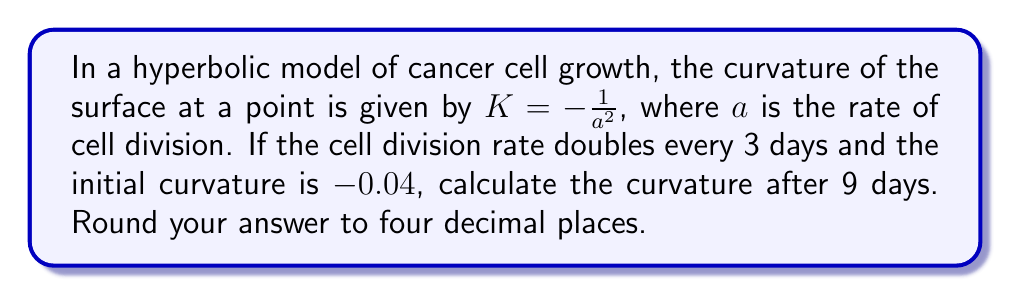Help me with this question. Let's approach this step-by-step:

1) The initial curvature is given as $K_0 = -0.04$

2) We know that $K = -\frac{1}{a^2}$, so initially:
   $-0.04 = -\frac{1}{a_0^2}$

3) Solving for $a_0$:
   $a_0^2 = \frac{1}{0.04} = 25$
   $a_0 = 5$

4) The cell division rate doubles every 3 days. After 9 days, it will have doubled 3 times.
   $a_9 = a_0 \cdot 2^3 = 5 \cdot 8 = 40$

5) Now we can calculate the new curvature:
   $K_9 = -\frac{1}{a_9^2} = -\frac{1}{40^2} = -\frac{1}{1600} = -0.000625$

6) Rounding to four decimal places: $-0.0006$
Answer: $-0.0006$ 